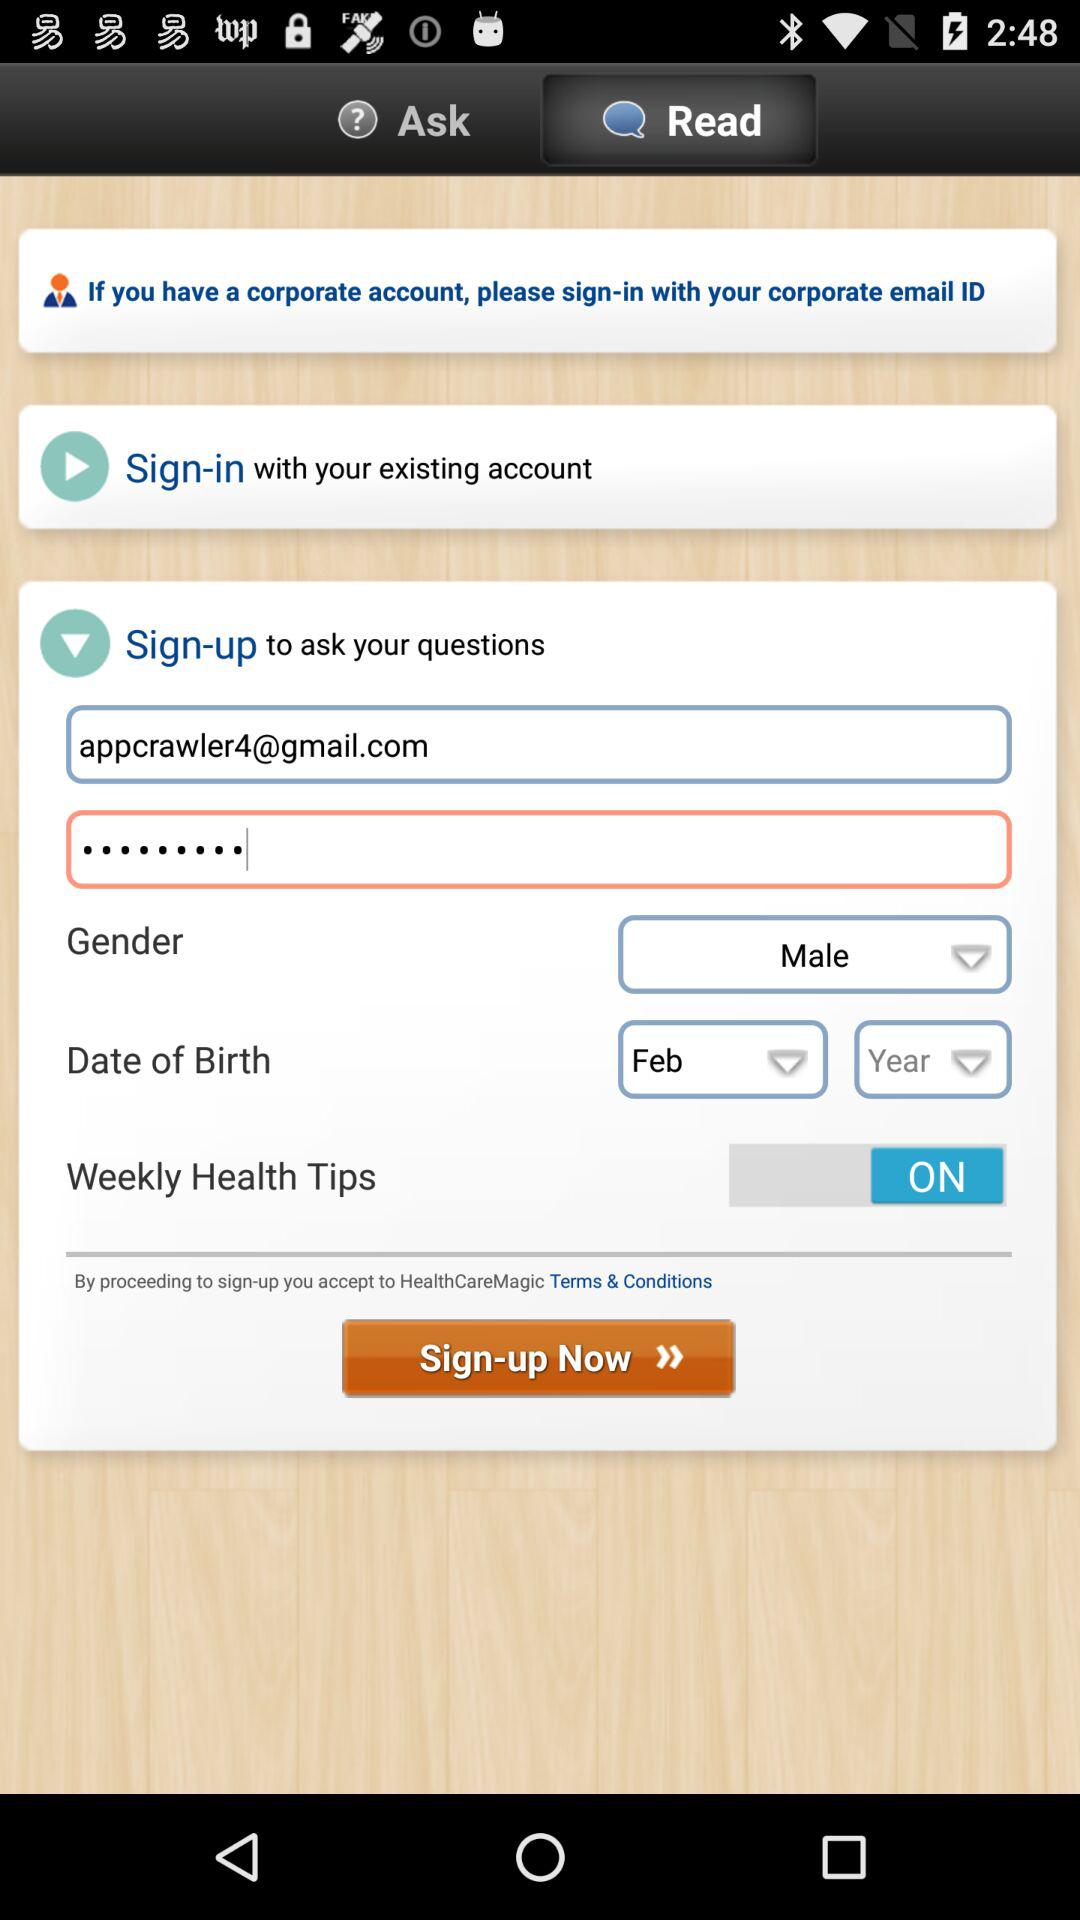What is the gender? The gender is male. 